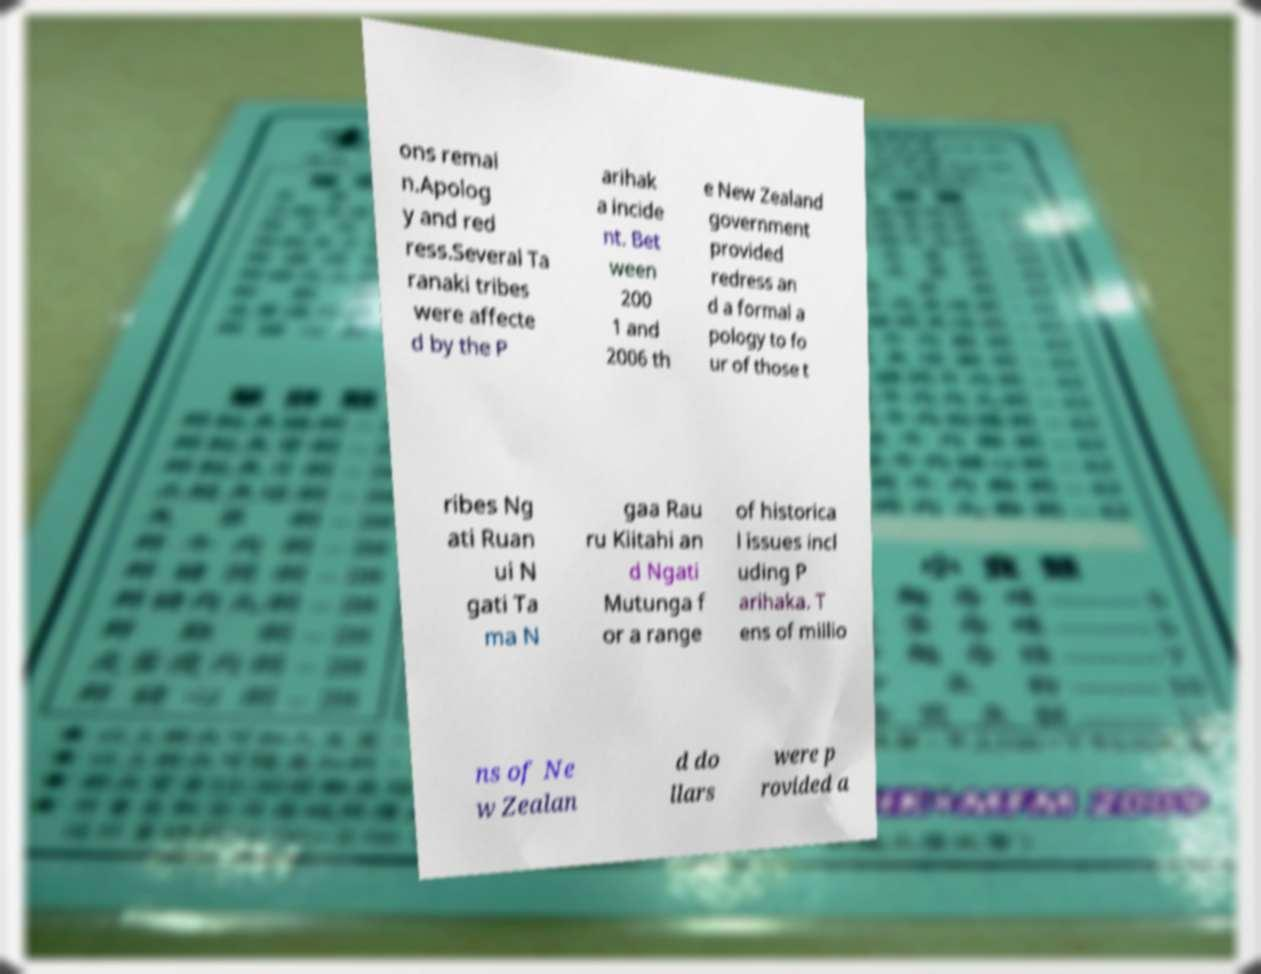Could you assist in decoding the text presented in this image and type it out clearly? ons remai n.Apolog y and red ress.Several Ta ranaki tribes were affecte d by the P arihak a incide nt. Bet ween 200 1 and 2006 th e New Zealand government provided redress an d a formal a pology to fo ur of those t ribes Ng ati Ruan ui N gati Ta ma N gaa Rau ru Kiitahi an d Ngati Mutunga f or a range of historica l issues incl uding P arihaka. T ens of millio ns of Ne w Zealan d do llars were p rovided a 